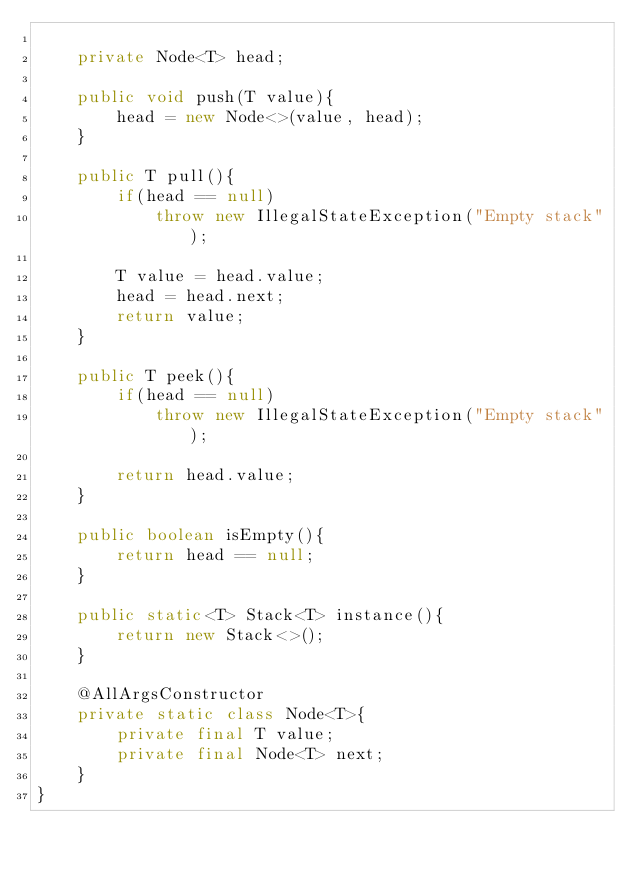Convert code to text. <code><loc_0><loc_0><loc_500><loc_500><_Java_>
    private Node<T> head;

    public void push(T value){
        head = new Node<>(value, head);
    }

    public T pull(){
        if(head == null)
            throw new IllegalStateException("Empty stack");

        T value = head.value;
        head = head.next;
        return value;
    }

    public T peek(){
        if(head == null)
            throw new IllegalStateException("Empty stack");

        return head.value;
    }

    public boolean isEmpty(){
        return head == null;
    }

    public static<T> Stack<T> instance(){
        return new Stack<>();
    }

    @AllArgsConstructor
    private static class Node<T>{
        private final T value;
        private final Node<T> next;
    }
}
</code> 